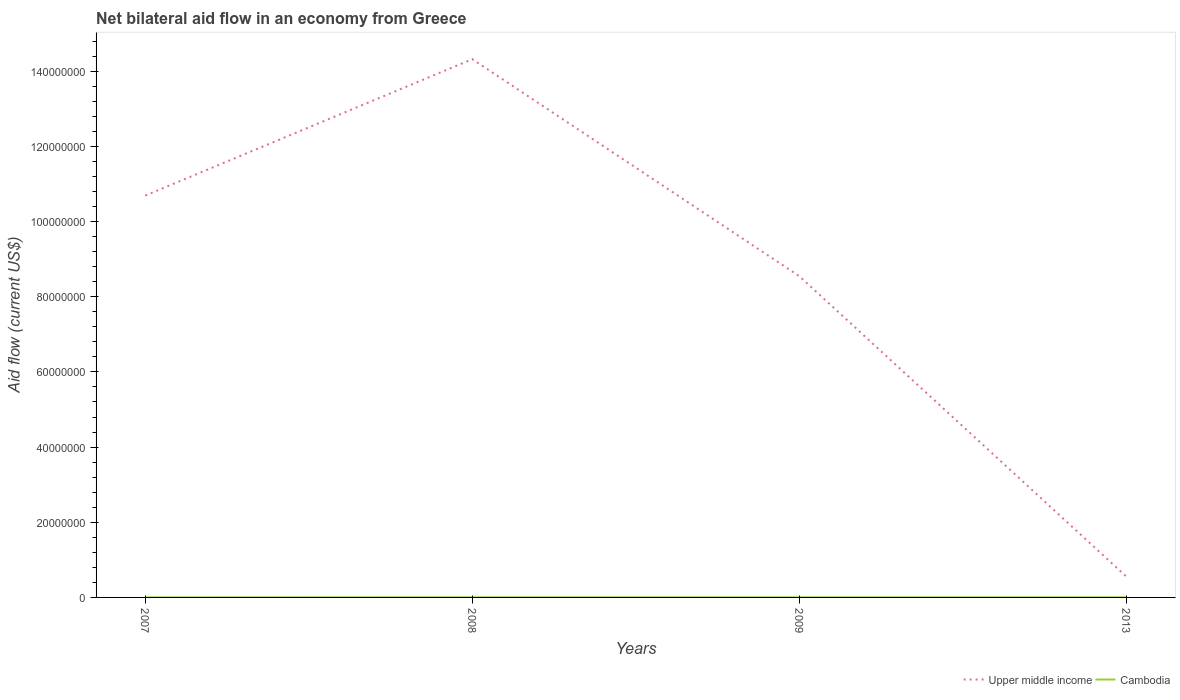Is the number of lines equal to the number of legend labels?
Your answer should be very brief. Yes. Across all years, what is the maximum net bilateral aid flow in Cambodia?
Your response must be concise. 10000. In which year was the net bilateral aid flow in Cambodia maximum?
Offer a terse response. 2007. What is the difference between the highest and the second highest net bilateral aid flow in Upper middle income?
Offer a terse response. 1.38e+08. What is the difference between the highest and the lowest net bilateral aid flow in Cambodia?
Your answer should be very brief. 1. Is the net bilateral aid flow in Upper middle income strictly greater than the net bilateral aid flow in Cambodia over the years?
Make the answer very short. No. Does the graph contain grids?
Your answer should be very brief. No. Where does the legend appear in the graph?
Keep it short and to the point. Bottom right. What is the title of the graph?
Your answer should be very brief. Net bilateral aid flow in an economy from Greece. Does "Senegal" appear as one of the legend labels in the graph?
Your response must be concise. No. What is the Aid flow (current US$) in Upper middle income in 2007?
Make the answer very short. 1.07e+08. What is the Aid flow (current US$) of Upper middle income in 2008?
Offer a very short reply. 1.43e+08. What is the Aid flow (current US$) in Cambodia in 2008?
Your response must be concise. 3.00e+04. What is the Aid flow (current US$) in Upper middle income in 2009?
Make the answer very short. 8.55e+07. What is the Aid flow (current US$) of Cambodia in 2009?
Give a very brief answer. 2.00e+04. What is the Aid flow (current US$) in Upper middle income in 2013?
Provide a succinct answer. 5.53e+06. Across all years, what is the maximum Aid flow (current US$) of Upper middle income?
Your answer should be compact. 1.43e+08. Across all years, what is the minimum Aid flow (current US$) in Upper middle income?
Provide a short and direct response. 5.53e+06. Across all years, what is the minimum Aid flow (current US$) in Cambodia?
Provide a short and direct response. 10000. What is the total Aid flow (current US$) of Upper middle income in the graph?
Give a very brief answer. 3.41e+08. What is the difference between the Aid flow (current US$) in Upper middle income in 2007 and that in 2008?
Give a very brief answer. -3.63e+07. What is the difference between the Aid flow (current US$) of Upper middle income in 2007 and that in 2009?
Your answer should be compact. 2.14e+07. What is the difference between the Aid flow (current US$) of Upper middle income in 2007 and that in 2013?
Ensure brevity in your answer.  1.01e+08. What is the difference between the Aid flow (current US$) of Upper middle income in 2008 and that in 2009?
Offer a terse response. 5.78e+07. What is the difference between the Aid flow (current US$) of Cambodia in 2008 and that in 2009?
Make the answer very short. 10000. What is the difference between the Aid flow (current US$) in Upper middle income in 2008 and that in 2013?
Offer a terse response. 1.38e+08. What is the difference between the Aid flow (current US$) in Cambodia in 2008 and that in 2013?
Your answer should be very brief. 10000. What is the difference between the Aid flow (current US$) of Upper middle income in 2009 and that in 2013?
Provide a succinct answer. 7.99e+07. What is the difference between the Aid flow (current US$) in Upper middle income in 2007 and the Aid flow (current US$) in Cambodia in 2008?
Ensure brevity in your answer.  1.07e+08. What is the difference between the Aid flow (current US$) in Upper middle income in 2007 and the Aid flow (current US$) in Cambodia in 2009?
Your response must be concise. 1.07e+08. What is the difference between the Aid flow (current US$) in Upper middle income in 2007 and the Aid flow (current US$) in Cambodia in 2013?
Ensure brevity in your answer.  1.07e+08. What is the difference between the Aid flow (current US$) in Upper middle income in 2008 and the Aid flow (current US$) in Cambodia in 2009?
Ensure brevity in your answer.  1.43e+08. What is the difference between the Aid flow (current US$) of Upper middle income in 2008 and the Aid flow (current US$) of Cambodia in 2013?
Your response must be concise. 1.43e+08. What is the difference between the Aid flow (current US$) of Upper middle income in 2009 and the Aid flow (current US$) of Cambodia in 2013?
Ensure brevity in your answer.  8.54e+07. What is the average Aid flow (current US$) in Upper middle income per year?
Make the answer very short. 8.53e+07. In the year 2007, what is the difference between the Aid flow (current US$) in Upper middle income and Aid flow (current US$) in Cambodia?
Give a very brief answer. 1.07e+08. In the year 2008, what is the difference between the Aid flow (current US$) in Upper middle income and Aid flow (current US$) in Cambodia?
Keep it short and to the point. 1.43e+08. In the year 2009, what is the difference between the Aid flow (current US$) in Upper middle income and Aid flow (current US$) in Cambodia?
Ensure brevity in your answer.  8.54e+07. In the year 2013, what is the difference between the Aid flow (current US$) in Upper middle income and Aid flow (current US$) in Cambodia?
Your response must be concise. 5.51e+06. What is the ratio of the Aid flow (current US$) of Upper middle income in 2007 to that in 2008?
Your response must be concise. 0.75. What is the ratio of the Aid flow (current US$) in Cambodia in 2007 to that in 2008?
Offer a very short reply. 0.33. What is the ratio of the Aid flow (current US$) in Upper middle income in 2007 to that in 2009?
Your answer should be compact. 1.25. What is the ratio of the Aid flow (current US$) of Upper middle income in 2007 to that in 2013?
Give a very brief answer. 19.33. What is the ratio of the Aid flow (current US$) in Upper middle income in 2008 to that in 2009?
Your answer should be compact. 1.68. What is the ratio of the Aid flow (current US$) of Cambodia in 2008 to that in 2009?
Make the answer very short. 1.5. What is the ratio of the Aid flow (current US$) in Upper middle income in 2008 to that in 2013?
Ensure brevity in your answer.  25.9. What is the ratio of the Aid flow (current US$) of Cambodia in 2008 to that in 2013?
Your answer should be compact. 1.5. What is the ratio of the Aid flow (current US$) in Upper middle income in 2009 to that in 2013?
Offer a terse response. 15.45. What is the ratio of the Aid flow (current US$) of Cambodia in 2009 to that in 2013?
Your response must be concise. 1. What is the difference between the highest and the second highest Aid flow (current US$) in Upper middle income?
Your answer should be compact. 3.63e+07. What is the difference between the highest and the lowest Aid flow (current US$) in Upper middle income?
Make the answer very short. 1.38e+08. What is the difference between the highest and the lowest Aid flow (current US$) in Cambodia?
Your response must be concise. 2.00e+04. 